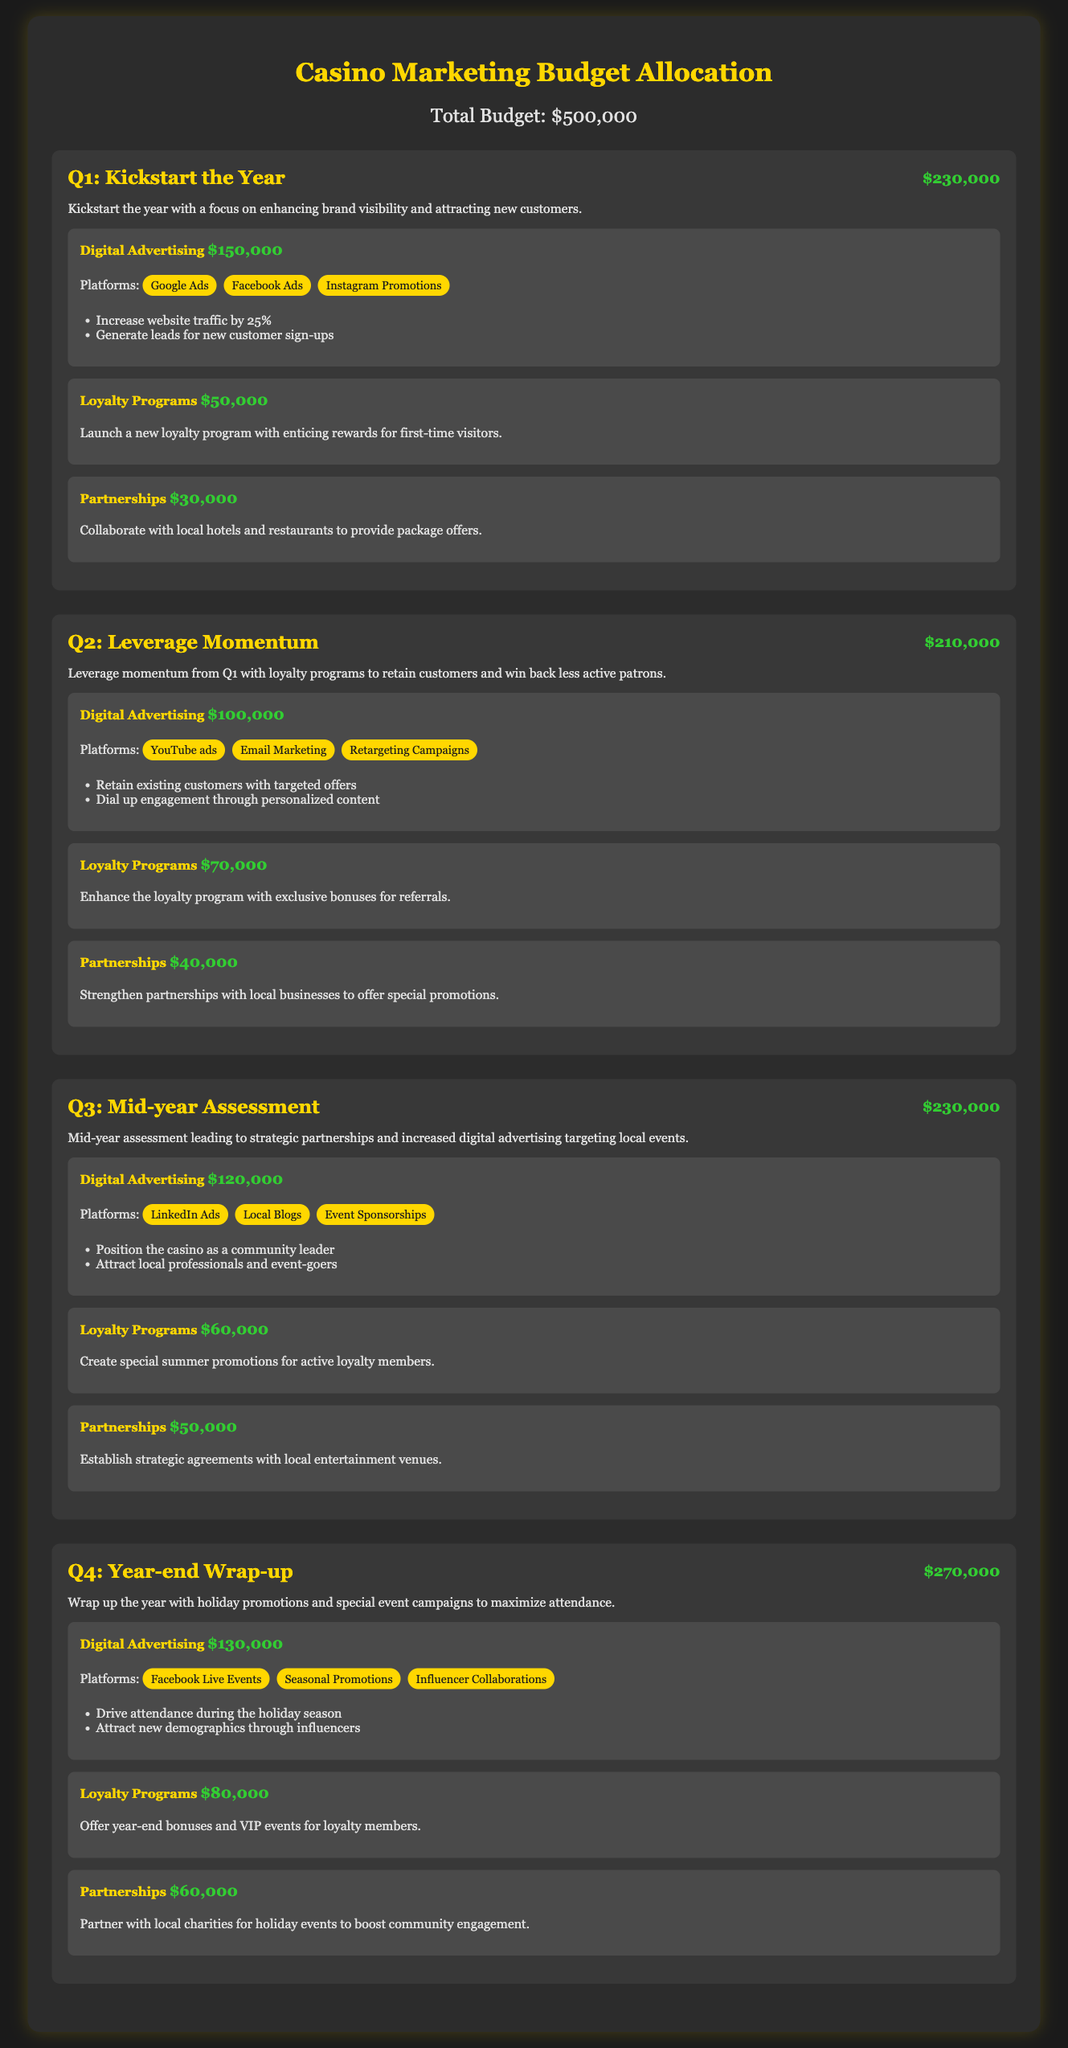What is the total marketing budget? The total marketing budget is explicitly stated at the beginning of the document as $500,000.
Answer: $500,000 How much is allocated for Q3? The allocation for Q3 is detailed in the document, specifying $230,000 for that quarter.
Answer: $230,000 What platforms will be used for digital advertising in Q2? The document lists specific advertising platforms for Q2, which include YouTube ads, Email Marketing, and Retargeting Campaigns.
Answer: YouTube ads, Email Marketing, Retargeting Campaigns What is the focus of Q1's campaign? The focus of Q1's campaign, mentioned in the document, is on enhancing brand visibility and attracting new customers.
Answer: Enhancing brand visibility and attracting new customers Which quarter has the highest budget allocation? By reviewing the allocations for each quarter, it’s determined that Q4 has the highest budget at $270,000.
Answer: Q4 How much is allocated for partnerships in Q1? The document provides specific figures for the partnerships category in Q1, which is $30,000.
Answer: $30,000 What is the main goal for the loyalty programs in Q2? The goal for Q2's loyalty programs, according to the document, is to enhance the loyalty program with exclusive bonuses for referrals.
Answer: Enhance the loyalty program with exclusive bonuses for referrals What is the combined total for digital advertising across all quarters? The combined total can be calculated by adding the digital advertising amounts for each quarter, giving a total of $500,000 ($150,000 + $100,000 + $120,000 + $130,000 = $500,000).
Answer: $500,000 Which local businesses will be partnered with in Q4? The document specifies that partnerships in Q4 will include collaborations with local charities for holiday events.
Answer: Local charities for holiday events 